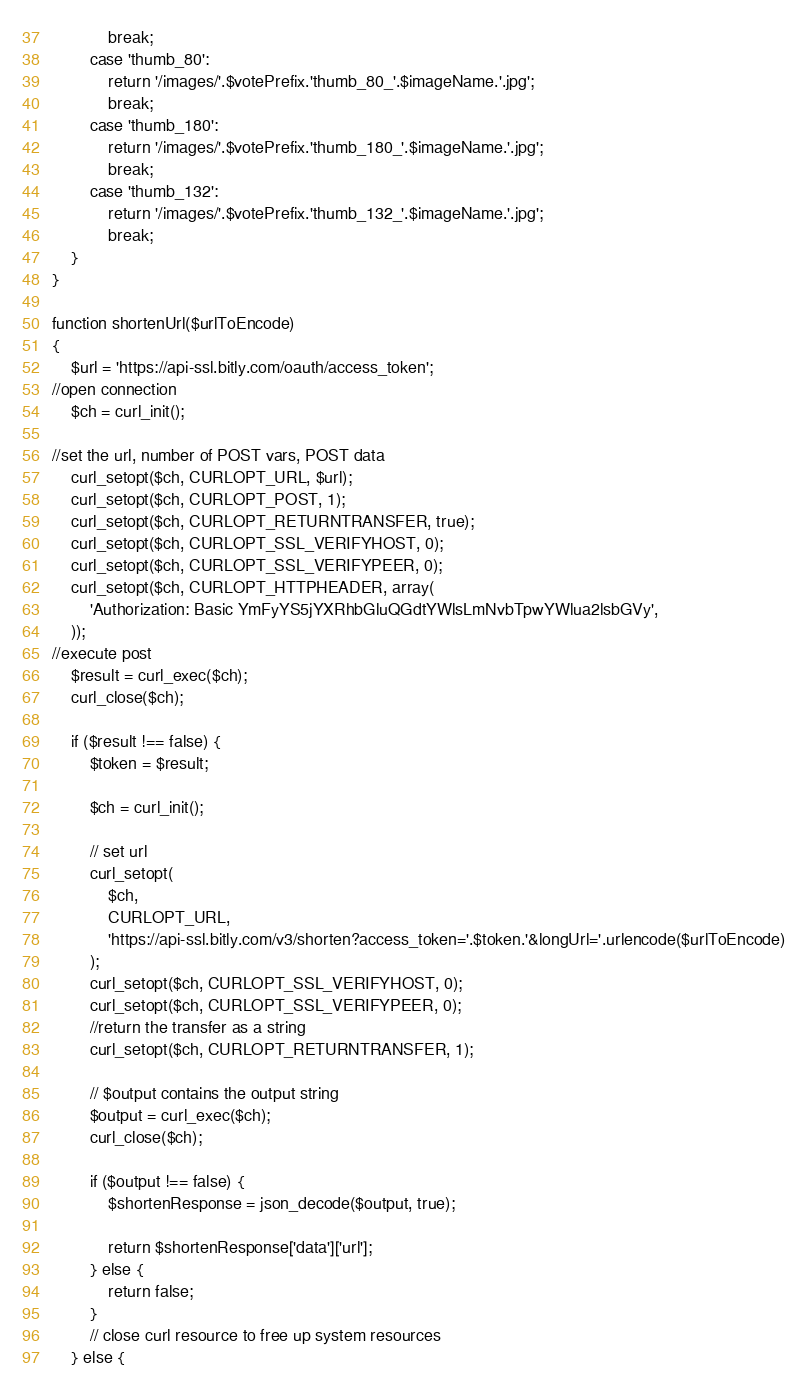<code> <loc_0><loc_0><loc_500><loc_500><_PHP_>            break;
        case 'thumb_80':
            return '/images/'.$votePrefix.'thumb_80_'.$imageName.'.jpg';
            break;
        case 'thumb_180':
            return '/images/'.$votePrefix.'thumb_180_'.$imageName.'.jpg';
            break;
        case 'thumb_132':
            return '/images/'.$votePrefix.'thumb_132_'.$imageName.'.jpg';
            break;
    }
}

function shortenUrl($urlToEncode)
{
    $url = 'https://api-ssl.bitly.com/oauth/access_token';
//open connection
    $ch = curl_init();

//set the url, number of POST vars, POST data
    curl_setopt($ch, CURLOPT_URL, $url);
    curl_setopt($ch, CURLOPT_POST, 1);
    curl_setopt($ch, CURLOPT_RETURNTRANSFER, true);
    curl_setopt($ch, CURLOPT_SSL_VERIFYHOST, 0);
    curl_setopt($ch, CURLOPT_SSL_VERIFYPEER, 0);
    curl_setopt($ch, CURLOPT_HTTPHEADER, array(
        'Authorization: Basic YmFyYS5jYXRhbGluQGdtYWlsLmNvbTpwYWlua2lsbGVy',
    ));
//execute post
    $result = curl_exec($ch);
    curl_close($ch);

    if ($result !== false) {
        $token = $result;

        $ch = curl_init();

        // set url
        curl_setopt(
            $ch,
            CURLOPT_URL,
            'https://api-ssl.bitly.com/v3/shorten?access_token='.$token.'&longUrl='.urlencode($urlToEncode)
        );
        curl_setopt($ch, CURLOPT_SSL_VERIFYHOST, 0);
        curl_setopt($ch, CURLOPT_SSL_VERIFYPEER, 0);
        //return the transfer as a string
        curl_setopt($ch, CURLOPT_RETURNTRANSFER, 1);

        // $output contains the output string
        $output = curl_exec($ch);
        curl_close($ch);

        if ($output !== false) {
            $shortenResponse = json_decode($output, true);

            return $shortenResponse['data']['url'];
        } else {
            return false;
        }
        // close curl resource to free up system resources
    } else {</code> 